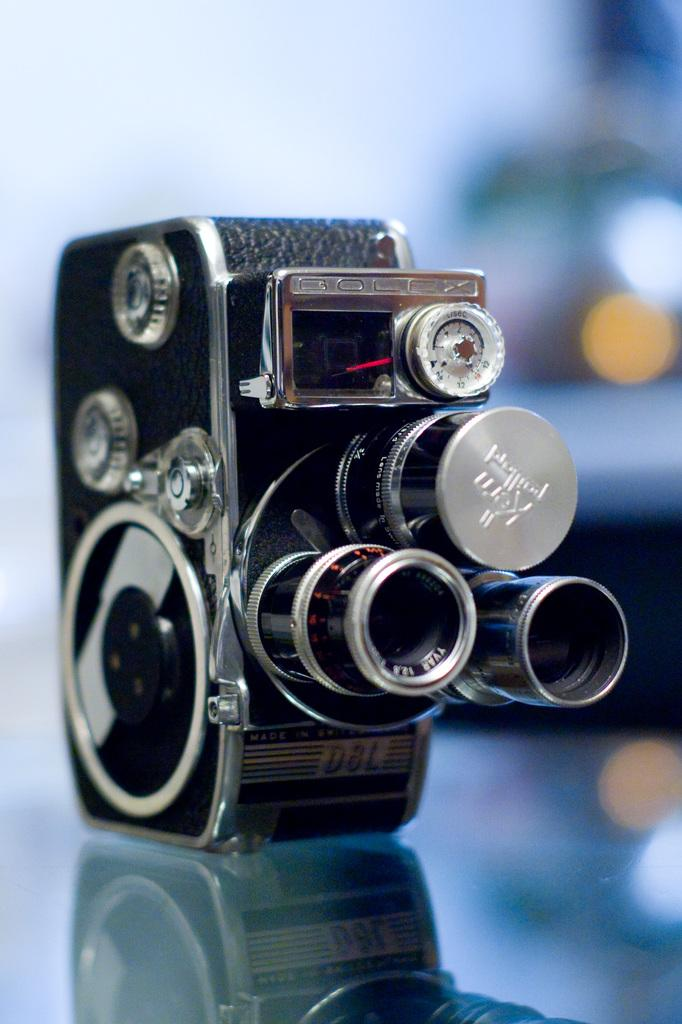What material is the object in the image made of? The object in the image is made up of stainless steel. What type of wax is used to create the statement on the object in the image? There is no wax or statement present on the object in the image; it is made up of stainless steel. 